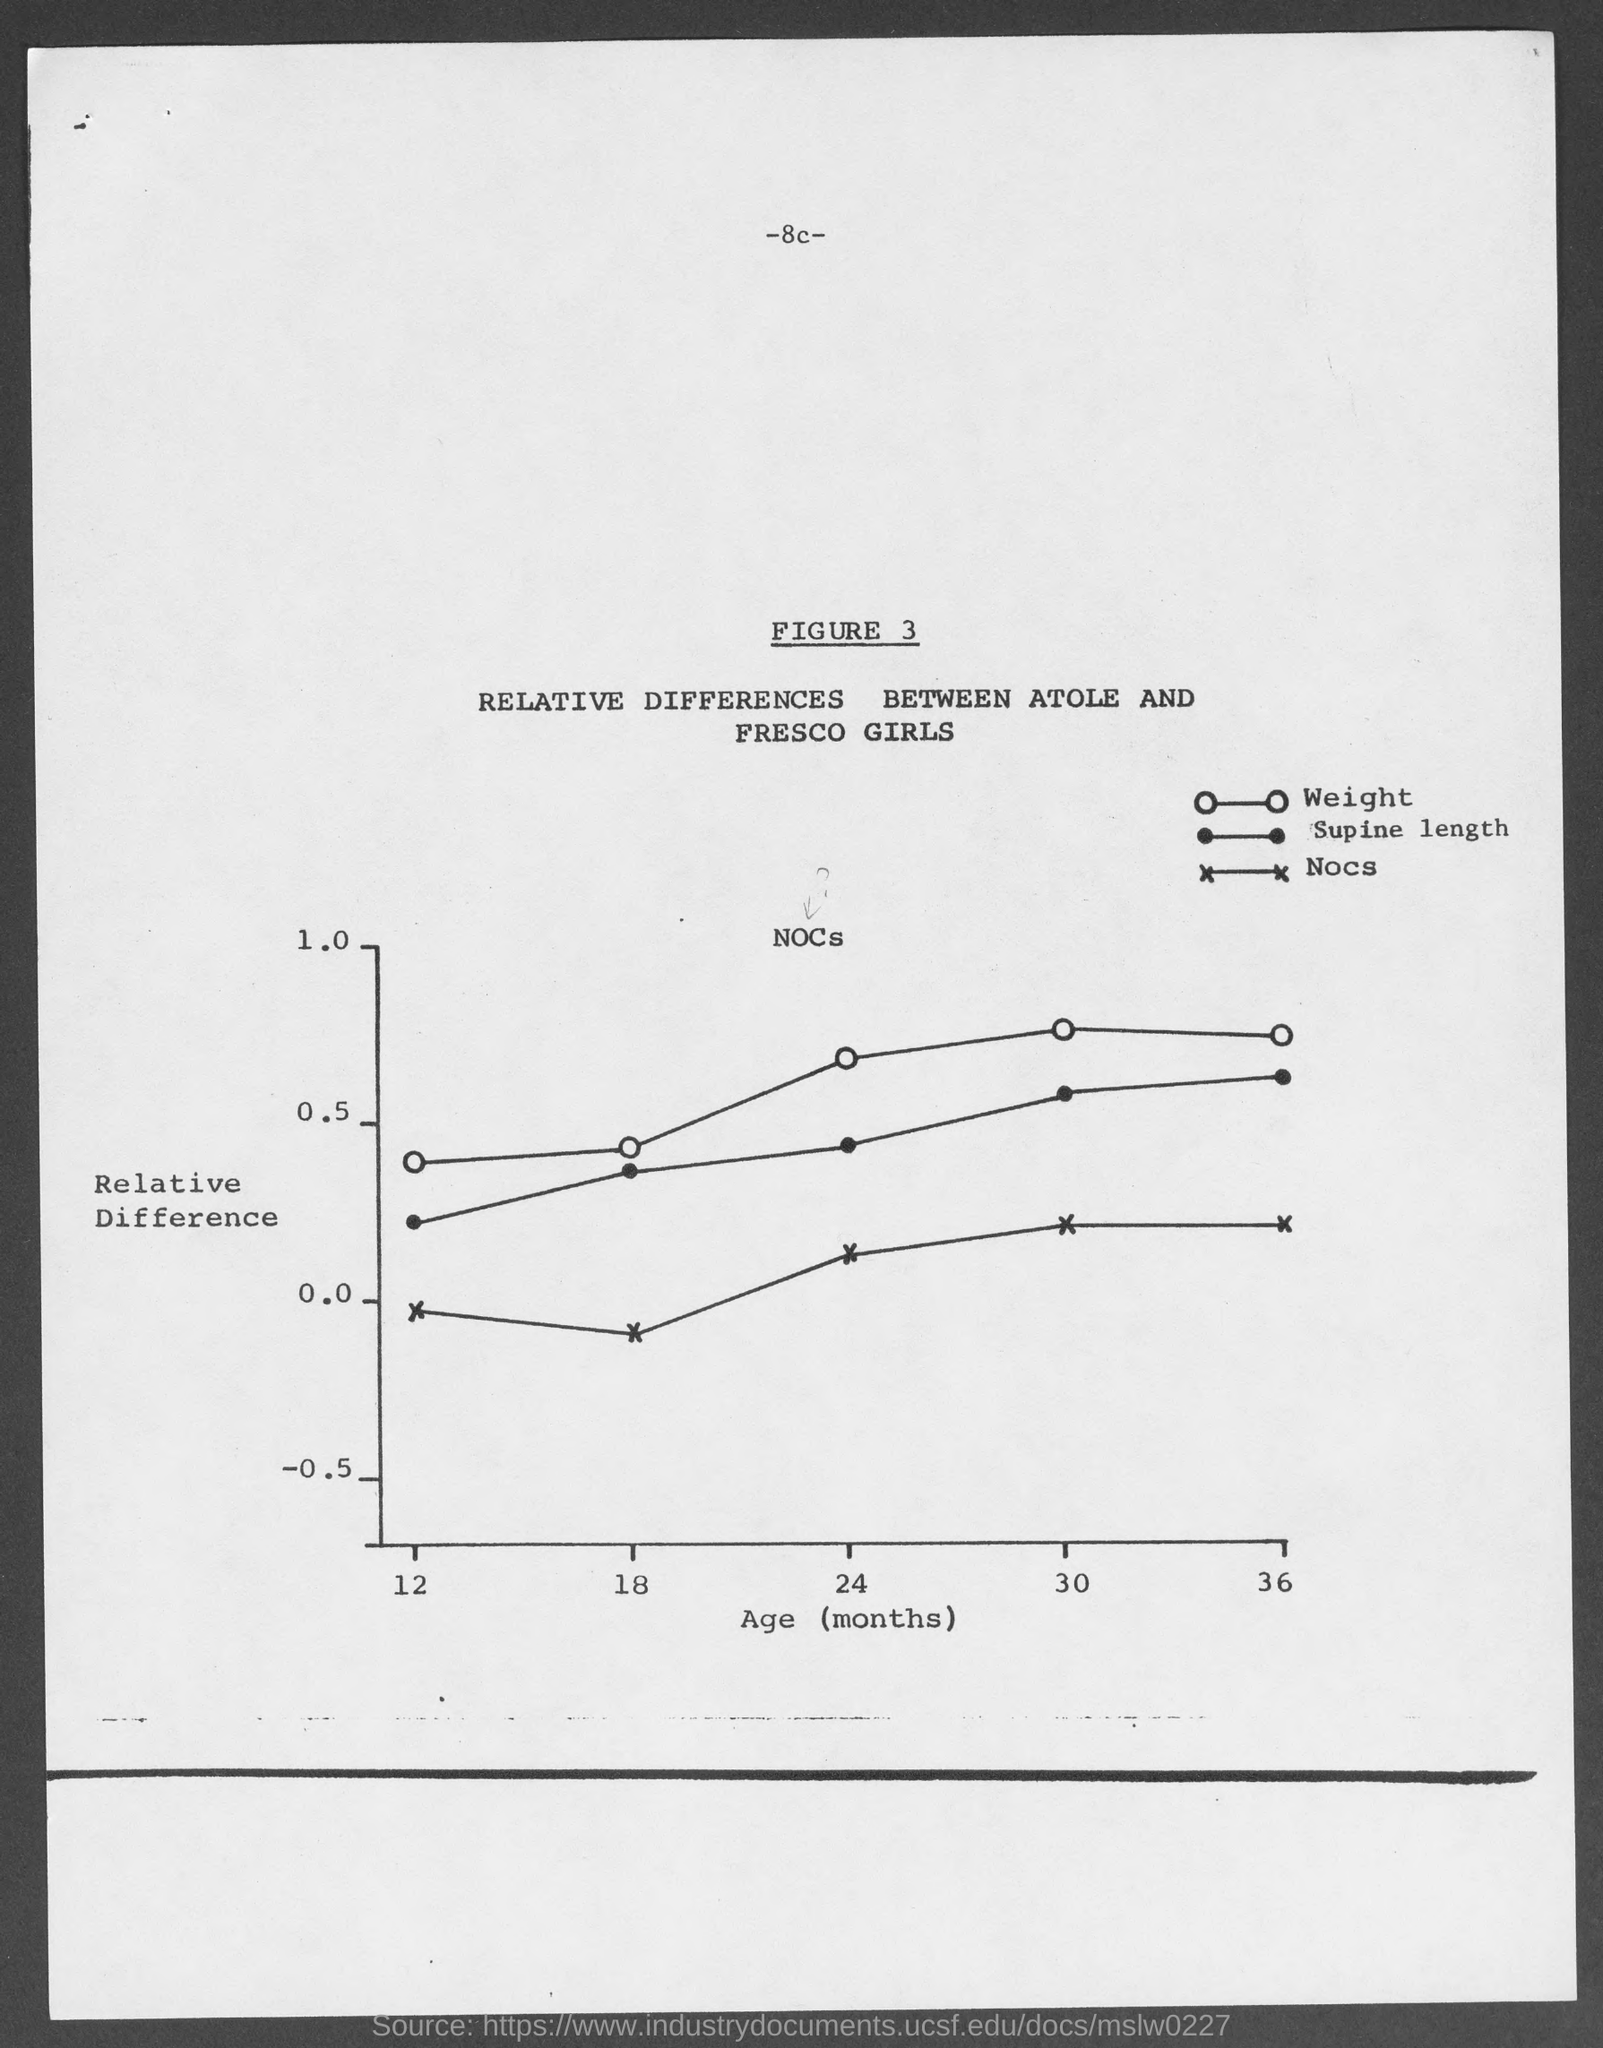Can you explain what is being measured in this figure? This chart, titled Figure 3, displays the relative differences in weight, supine length, and nocs between Atole and Fresco girls over a period ranging from 12 to 36 months of age. It's a comparative study to show the growth patterns in these two groups. 